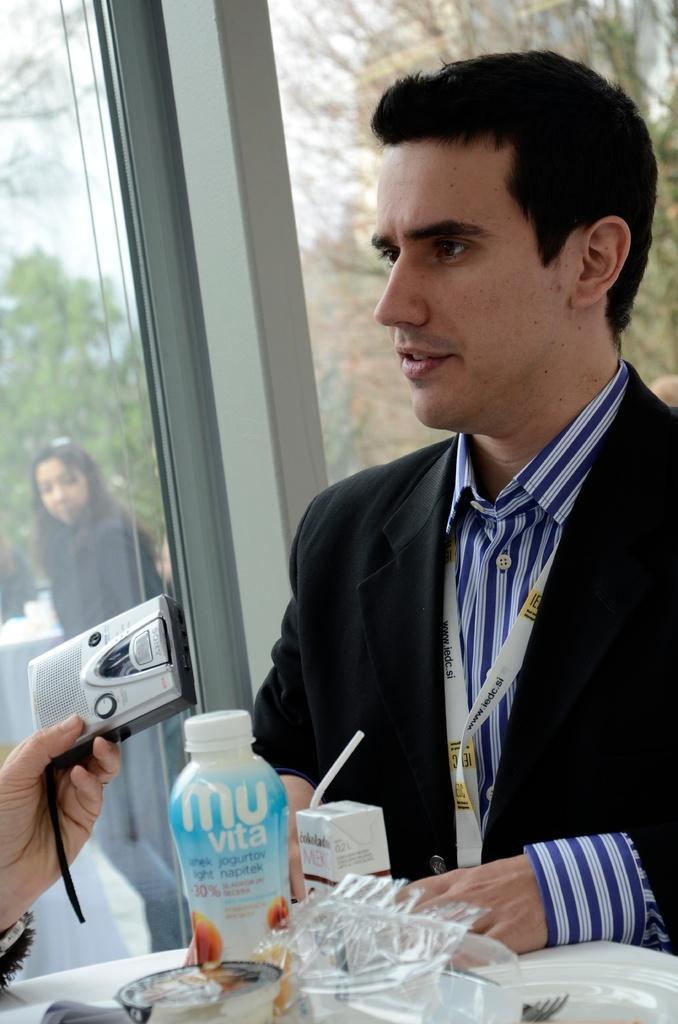Can you describe this image briefly? In this image I can see a man wearing a suit and sitting. This is a table where a bottle,bowl,plate,fork are placed on it. At background I can see women standing. At the left corner of the image I can see a person's hand holding a recorder. 